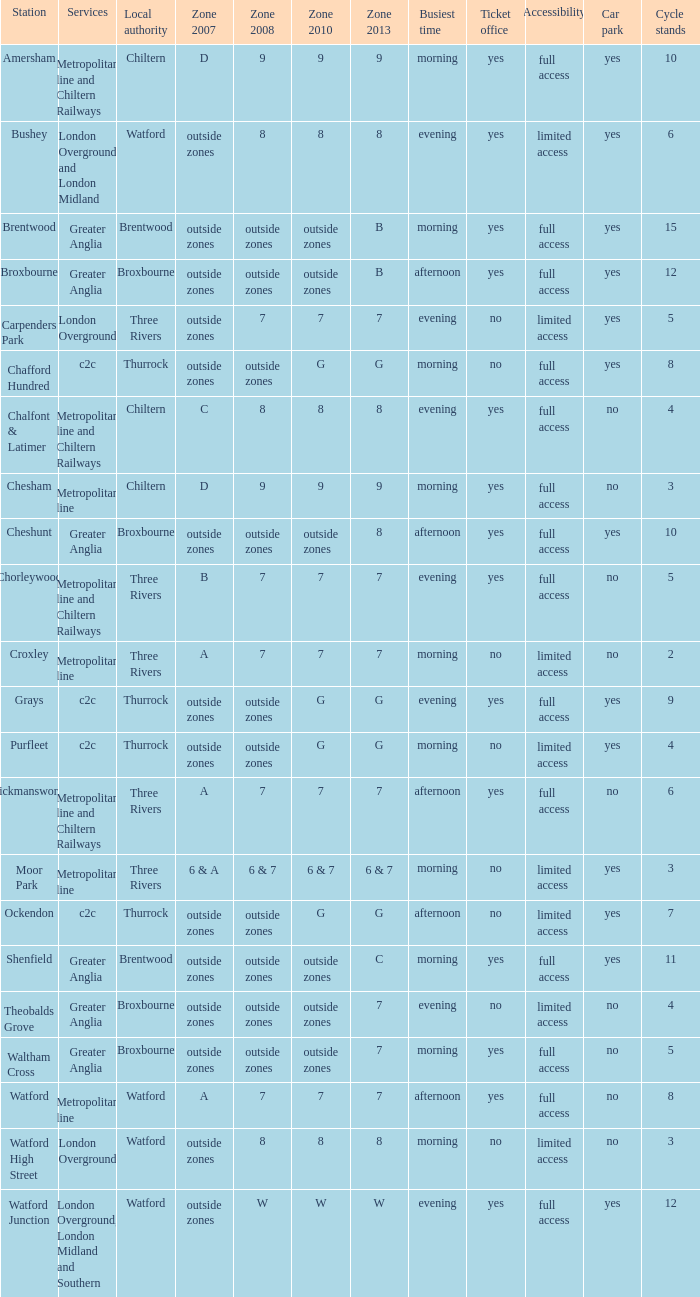Which Local authority has Services of greater anglia? Brentwood, Broxbourne, Broxbourne, Brentwood, Broxbourne, Broxbourne. 